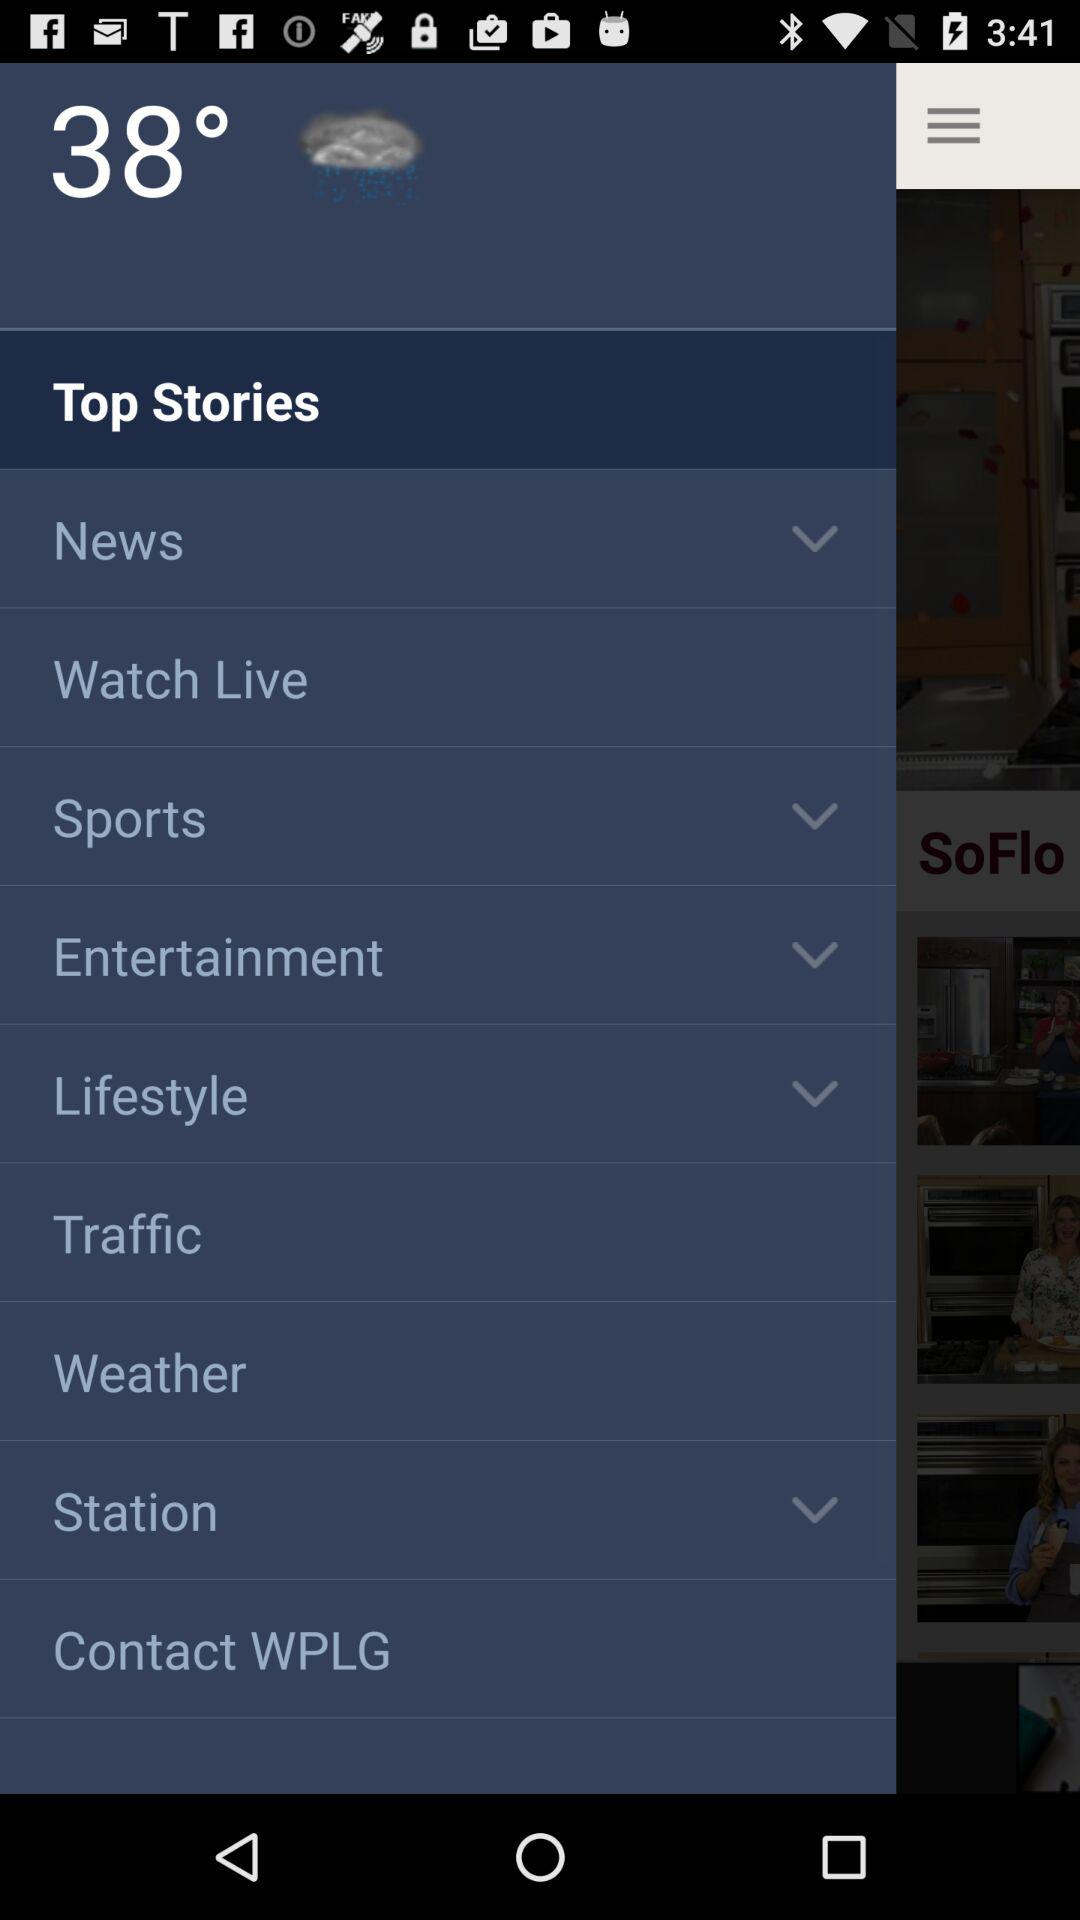What is the temperature? The temperature is 38 degrees. 